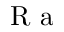Convert formula to latex. <formula><loc_0><loc_0><loc_500><loc_500>R a</formula> 